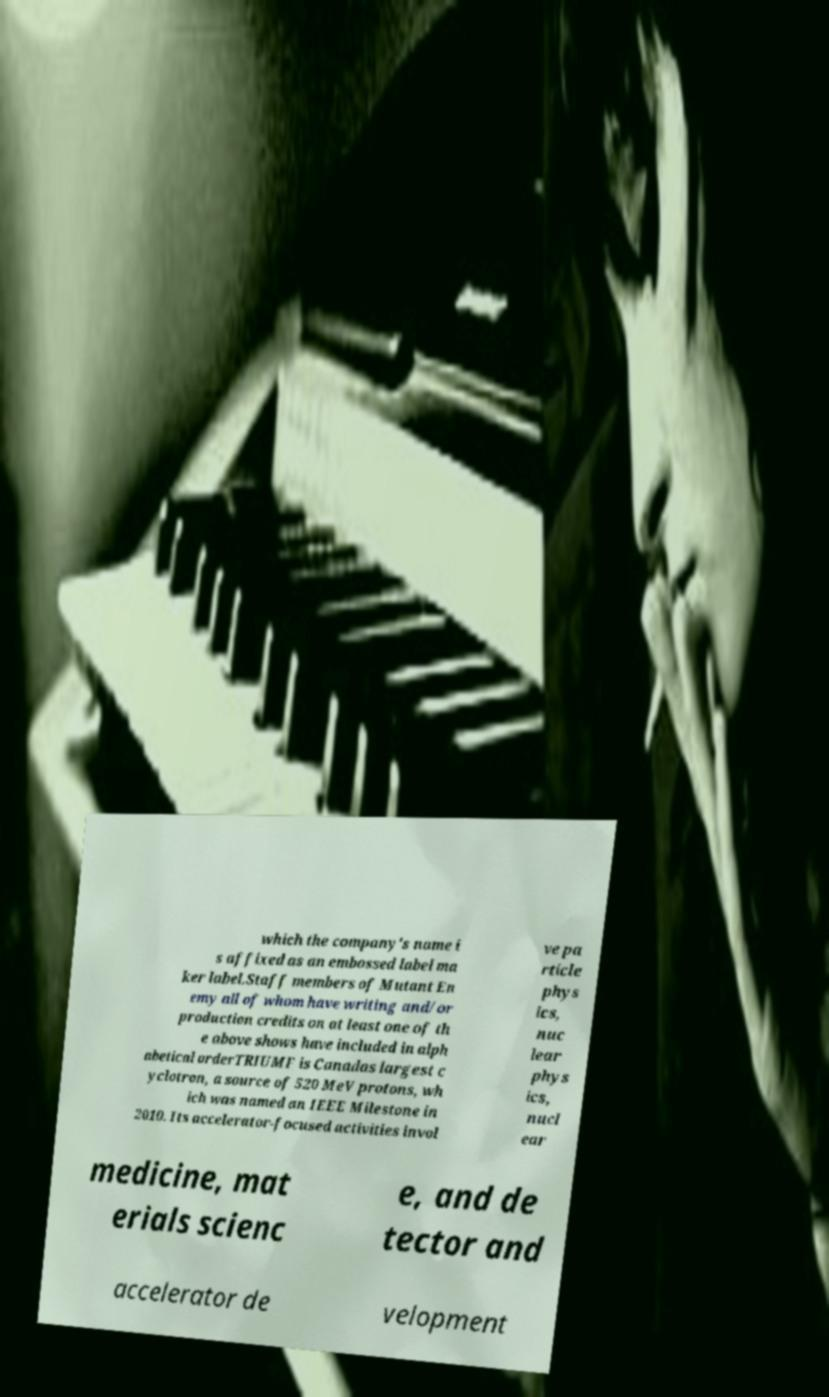I need the written content from this picture converted into text. Can you do that? which the company's name i s affixed as an embossed label ma ker label.Staff members of Mutant En emy all of whom have writing and/or production credits on at least one of th e above shows have included in alph abetical orderTRIUMF is Canadas largest c yclotron, a source of 520 MeV protons, wh ich was named an IEEE Milestone in 2010. Its accelerator-focused activities invol ve pa rticle phys ics, nuc lear phys ics, nucl ear medicine, mat erials scienc e, and de tector and accelerator de velopment 